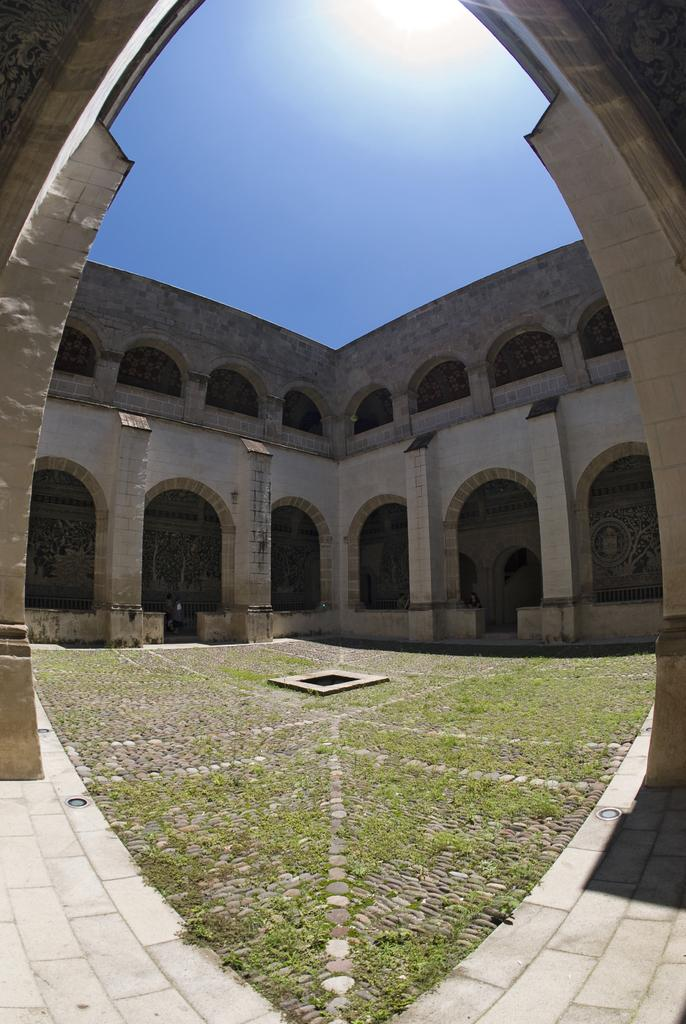What type of structure is present in the image? There is a building in the image. What can be seen in the background of the image? The sky is visible in the background of the image. How many brothers are present in the image? There are no people, including brothers, present in the image; it only features a building and the sky. 